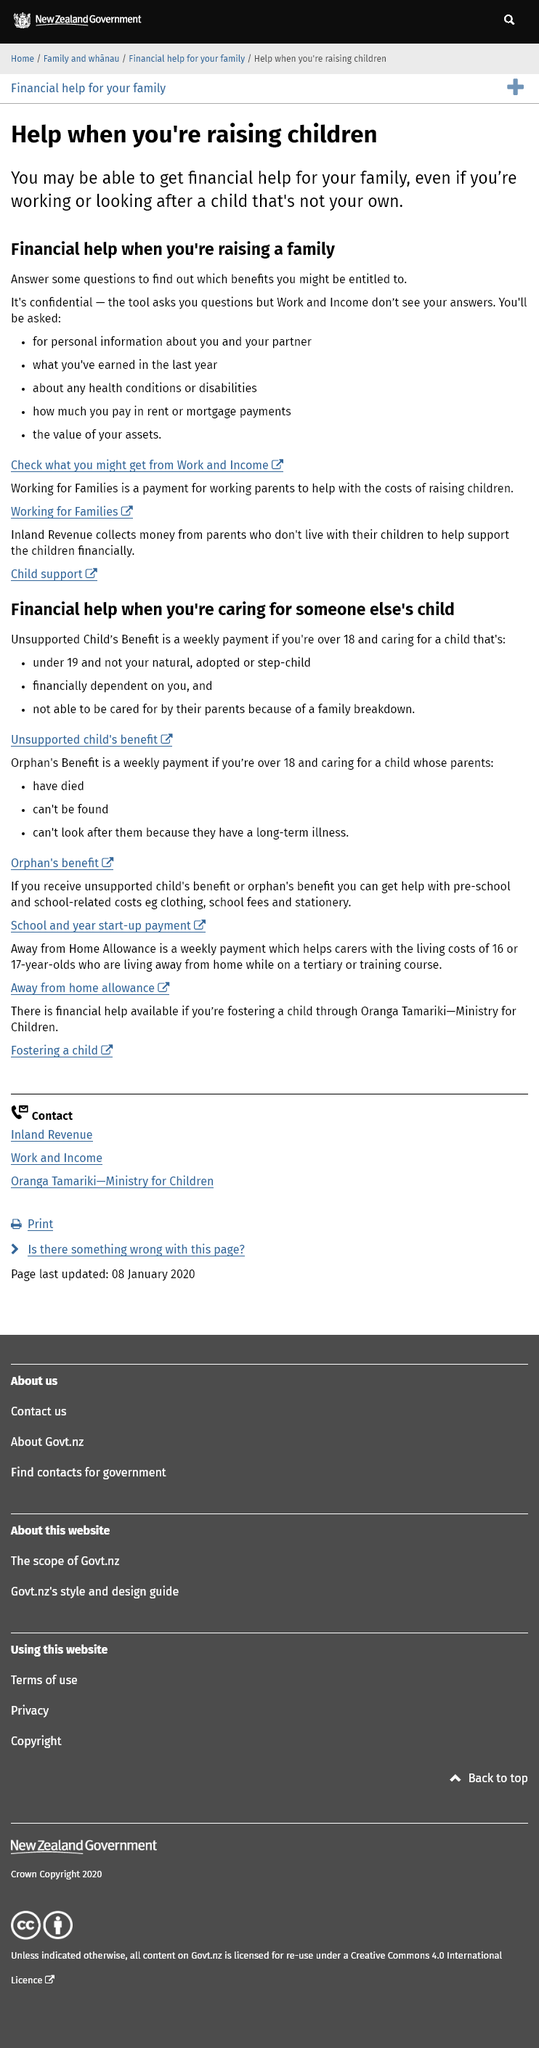Outline some significant characteristics in this image. In the process of applying for financial assistance to raise a child, potential recipients may be asked to provide details about their most recent income, rent or mortgage payments, and the value of their assets. Yes, it is possible to obtain financial assistance when raising a child that is not biologically yours. To determine if financial assistance is available to raise children, it is necessary to answer a series of confidential questions. 